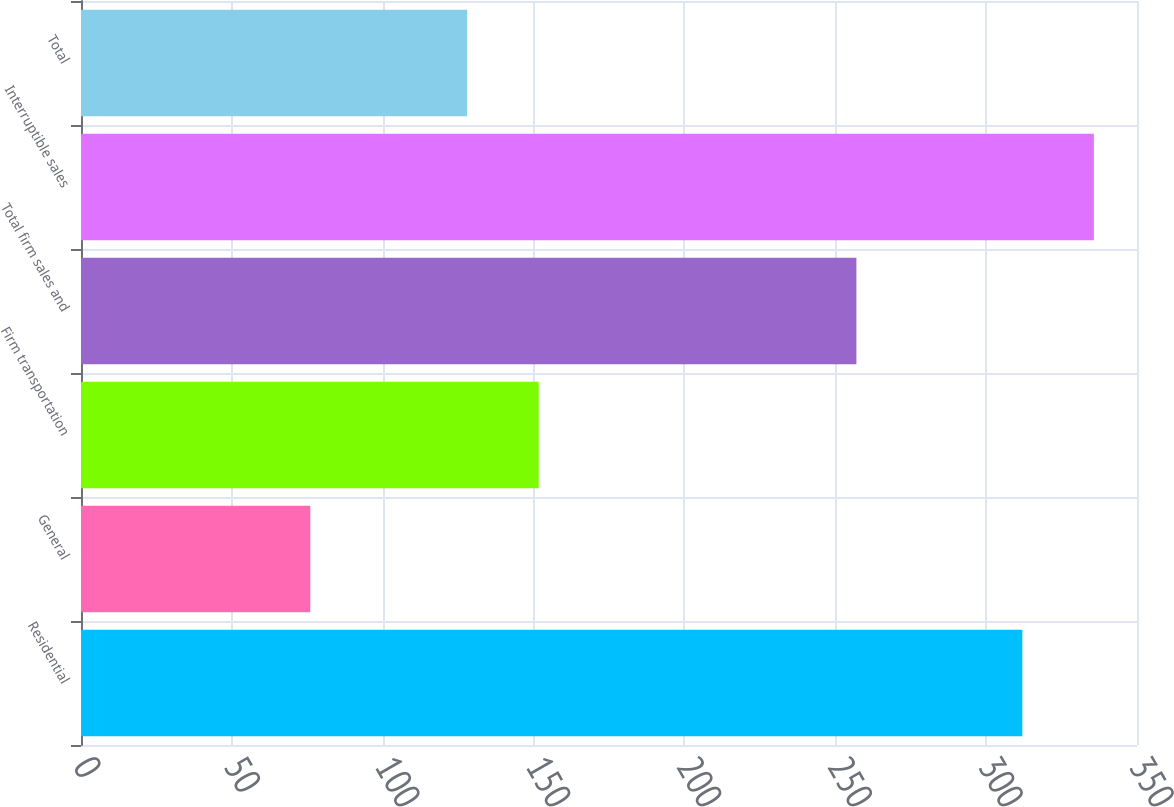Convert chart. <chart><loc_0><loc_0><loc_500><loc_500><bar_chart><fcel>Residential<fcel>General<fcel>Firm transportation<fcel>Total firm sales and<fcel>Interruptible sales<fcel>Total<nl><fcel>312<fcel>76<fcel>151.7<fcel>257<fcel>335.7<fcel>128<nl></chart> 